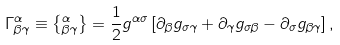Convert formula to latex. <formula><loc_0><loc_0><loc_500><loc_500>\Gamma _ { \beta \gamma } ^ { \alpha } \equiv \left \{ _ { \beta \gamma } ^ { \alpha } \right \} = \frac { 1 } { 2 } g ^ { \alpha \sigma } \left [ \partial _ { \beta } g _ { \sigma \gamma } + \partial _ { \gamma } g _ { \sigma \beta } - \partial _ { \sigma } g _ { \beta \gamma } \right ] ,</formula> 